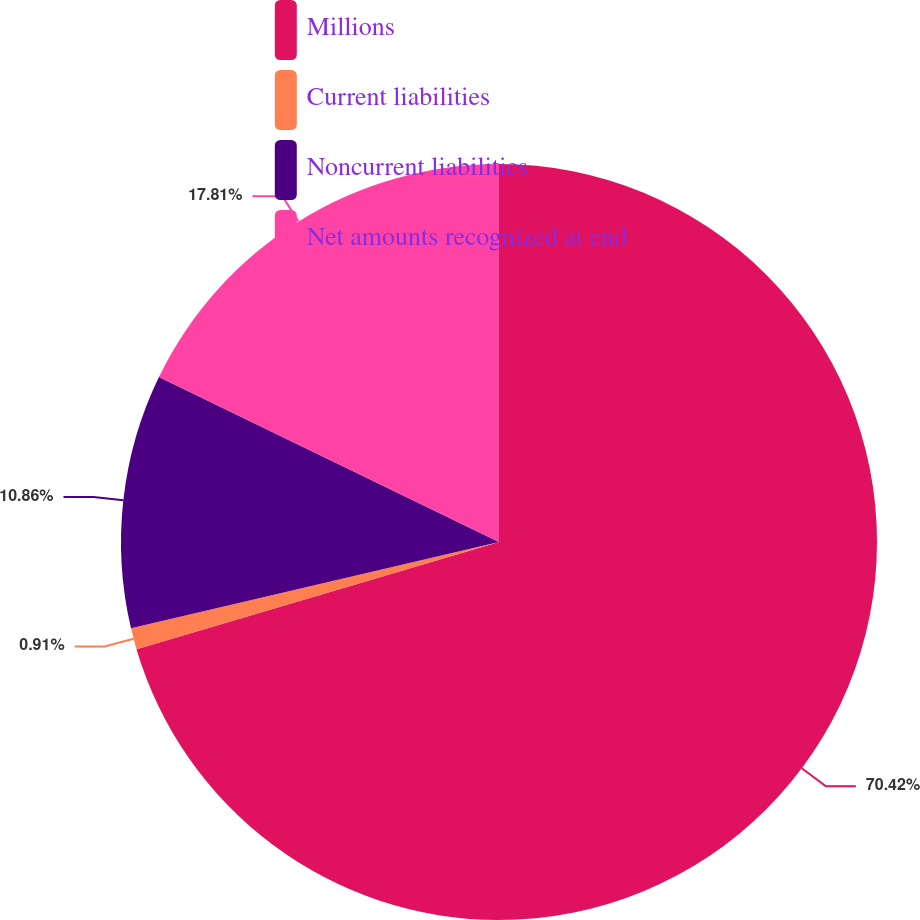<chart> <loc_0><loc_0><loc_500><loc_500><pie_chart><fcel>Millions<fcel>Current liabilities<fcel>Noncurrent liabilities<fcel>Net amounts recognized at end<nl><fcel>70.43%<fcel>0.91%<fcel>10.86%<fcel>17.81%<nl></chart> 